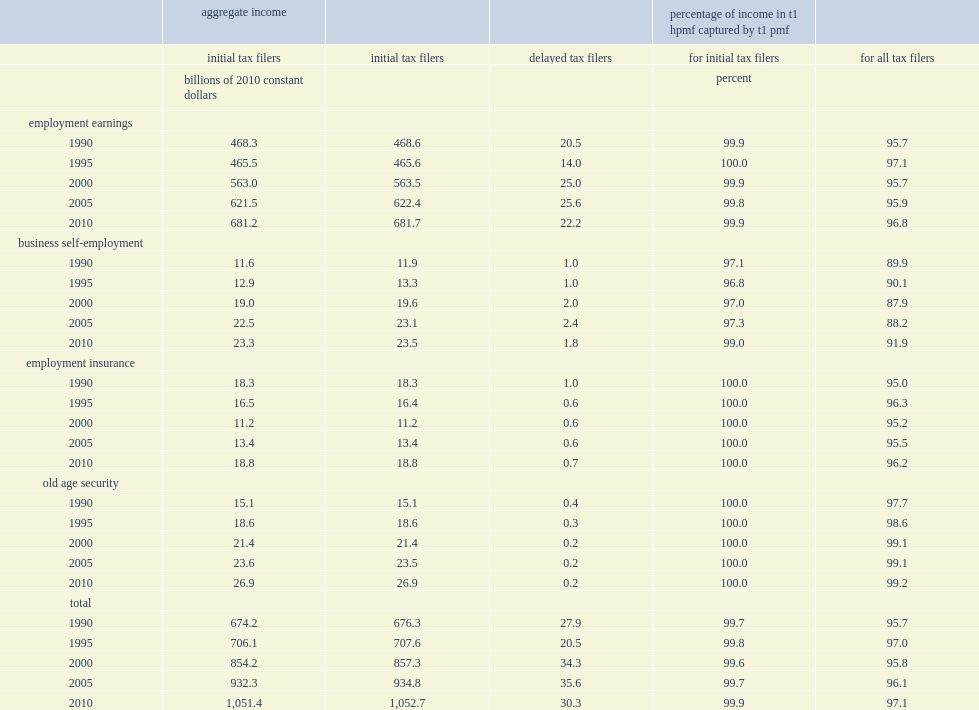What was the total employment earnings among initial tax filers in 1990 based on the t1 pmf data? 468.3. What was the total employment earnings among initial tax filers in 2010 based on the t1 pmf data? 681.2. What was the total employment earnings among initial tax filers in 1990 based on the t1 hpmf data? 468.6. What was the total employment earnings among initial tax filers in 2010 based on the t1 hpmf data? 681.7. In 1990, what was the estimated sum of all ei payments to initial tax filers in the t1 hpmf? 18.3. In 1990, what was the estimated sum of all ei payments to initial tax filers in the t1 pmf? 18.3. What was the percentage of the aggregate values of ei incomes of initial tax filers in the t1 hpmf captured by t1 pmf? 100.0. What was the percentage of the aggregate values of oas incomes of initial tax filers in the t1 hpmf captured by t1 pmf? 100.0. What was the percentage of business self-employment income of initial tax filers in the t1 hpmf captured by t1 pmf in 1995? 96.8. What was the percentage of business self-employment income of initial tax filers in the t1 hpmf captured by t1 pmf in 2010? 99.0. In 1990, what was the total aggregate employment earnings among delayed tax filers? 20.5. In 1990,what was the percentage of employment earnings of total employment earnings in the t1 hpmf captured by t1 pmf? 95.7. How many percentage point of the t1 pmf had captured of all business self-employment income in the t1 hpmf in 2000? 87.9. How many percentage point of the t1 pmf had captured of all business self-employment income in the t1 hpmf in 2010? 91.9. 